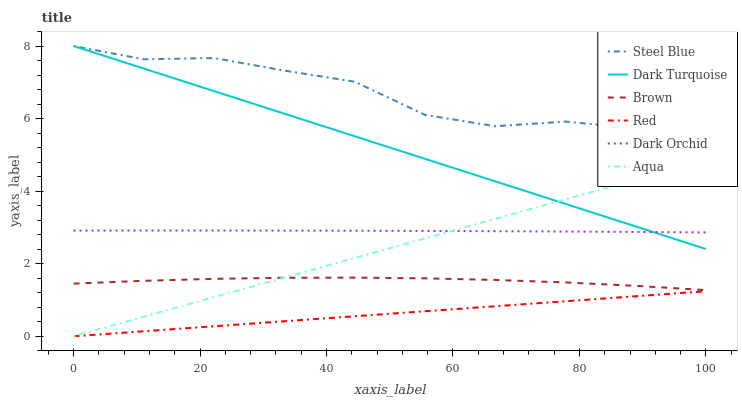Does Red have the minimum area under the curve?
Answer yes or no. Yes. Does Steel Blue have the maximum area under the curve?
Answer yes or no. Yes. Does Dark Turquoise have the minimum area under the curve?
Answer yes or no. No. Does Dark Turquoise have the maximum area under the curve?
Answer yes or no. No. Is Red the smoothest?
Answer yes or no. Yes. Is Steel Blue the roughest?
Answer yes or no. Yes. Is Dark Turquoise the smoothest?
Answer yes or no. No. Is Dark Turquoise the roughest?
Answer yes or no. No. Does Aqua have the lowest value?
Answer yes or no. Yes. Does Dark Turquoise have the lowest value?
Answer yes or no. No. Does Steel Blue have the highest value?
Answer yes or no. Yes. Does Aqua have the highest value?
Answer yes or no. No. Is Brown less than Steel Blue?
Answer yes or no. Yes. Is Dark Orchid greater than Brown?
Answer yes or no. Yes. Does Brown intersect Aqua?
Answer yes or no. Yes. Is Brown less than Aqua?
Answer yes or no. No. Is Brown greater than Aqua?
Answer yes or no. No. Does Brown intersect Steel Blue?
Answer yes or no. No. 